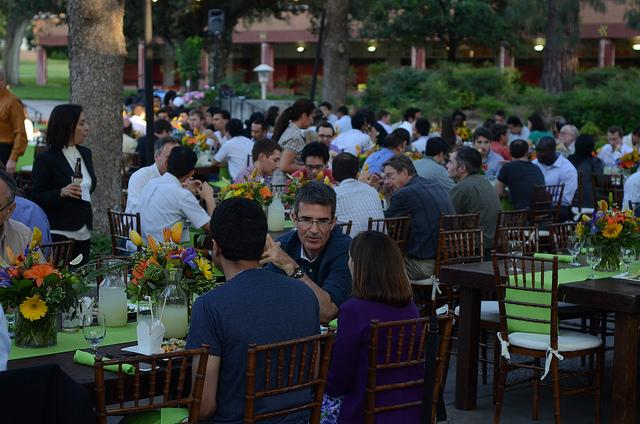What type of event is this? Please explain your reasoning. reception. People are sitting at decorated tables outdoors. 